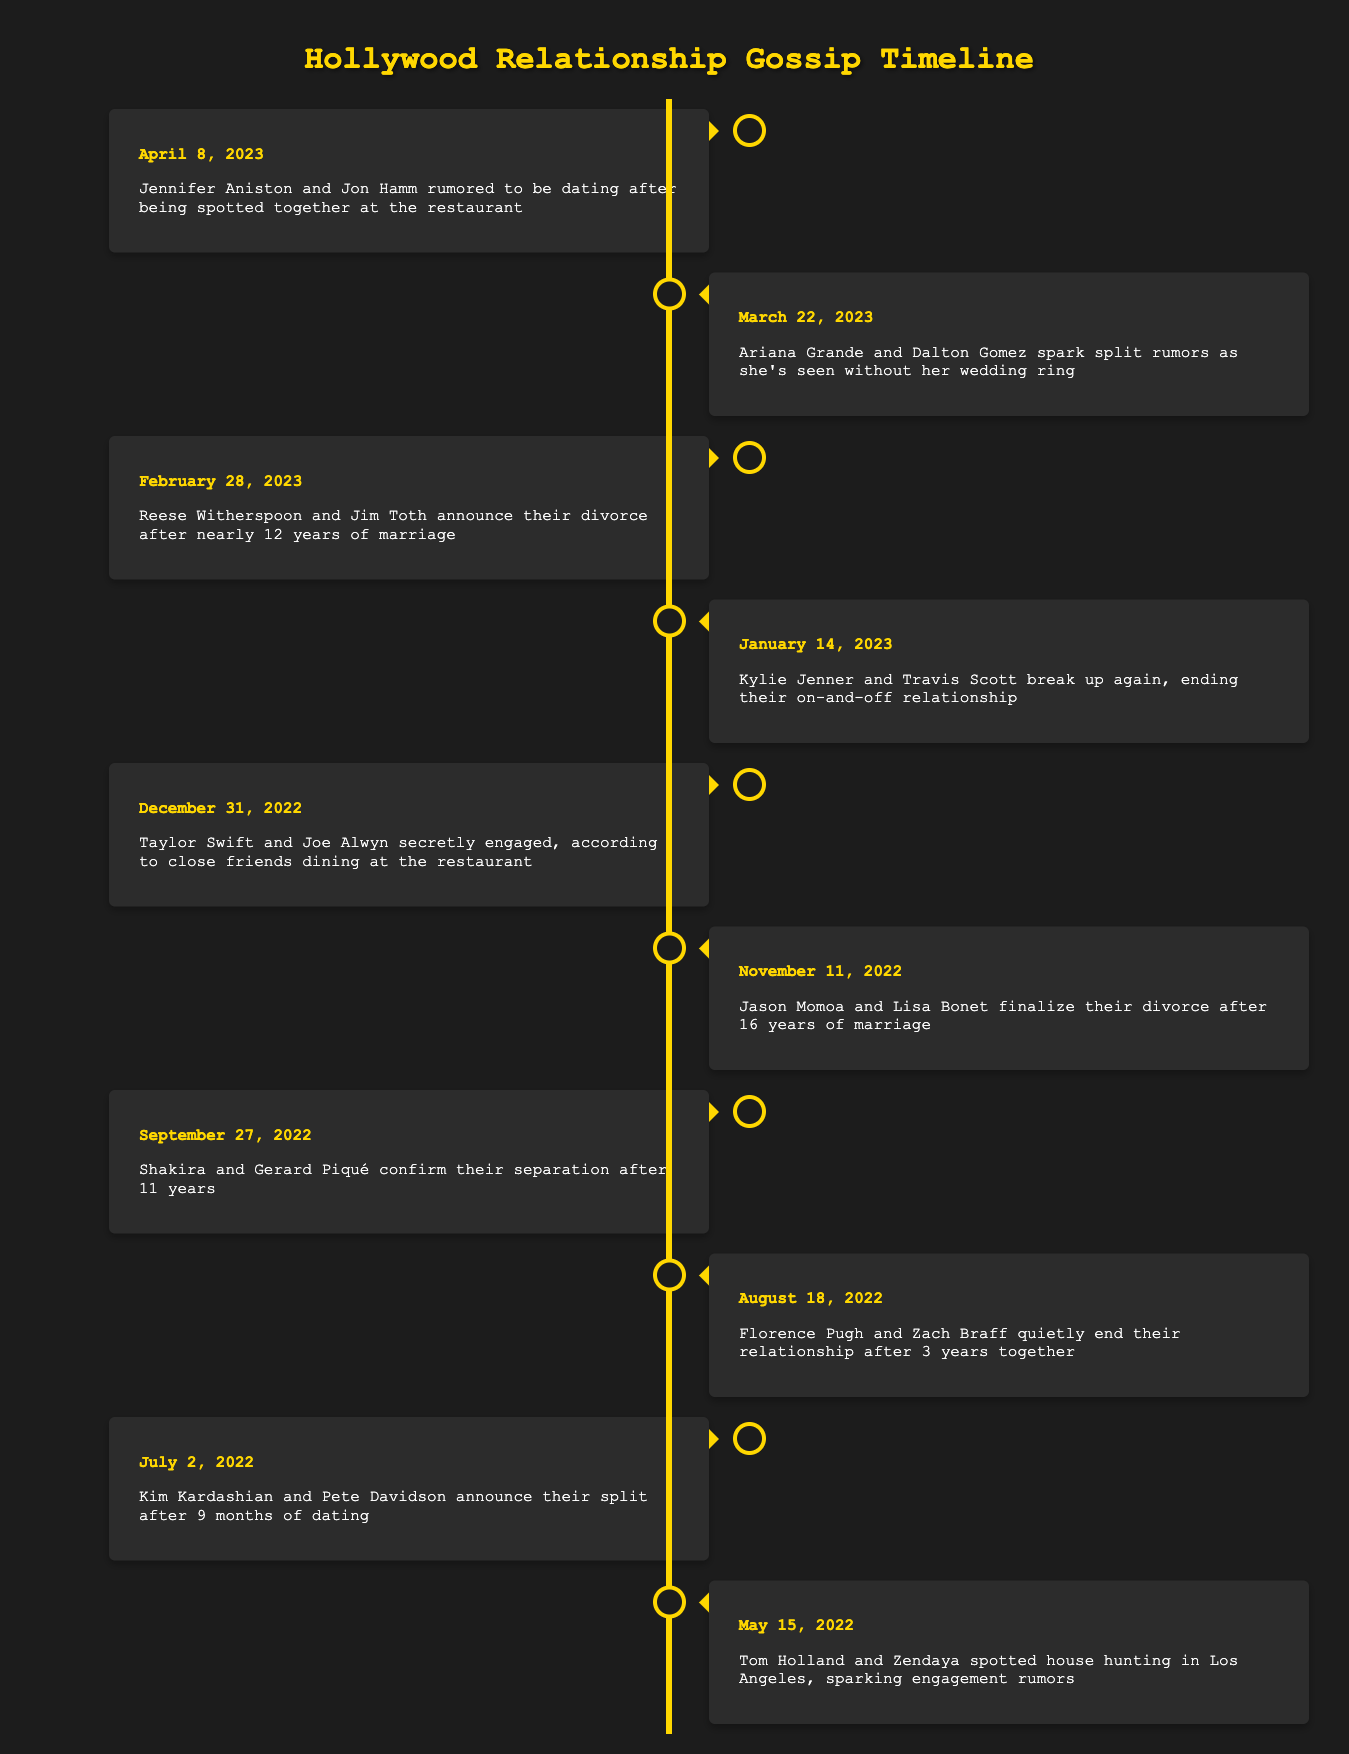What was the date when Tom Holland and Zendaya were first rumored to be engaged? According to the table, the event where Tom Holland and Zendaya were spotted house hunting, sparking engagement rumors, occurred on May 15, 2022.
Answer: May 15, 2022 How many celebrity relationships ended in the timeline provided? By carefully reviewing the events, Kim Kardashian and Pete Davidson, Florence Pugh and Zach Braff, Shakira and Gerard Piqué, Jason Momoa and Lisa Bonet, Kylie Jenner and Travis Scott, and Reese Witherspoon and Jim Toth all ended their relationships. This totals to 6 relationship endings.
Answer: 6 Is it true that Jennifer Aniston was rumored to be dating Jon Hamm? Yes, the table indicates that Jennifer Aniston and Jon Hamm were indeed rumored to be dating after being seen together at the restaurant on April 8, 2023.
Answer: Yes Which couple announced their divorce after the longest marriage? Jason Momoa and Lisa Bonet finalized their divorce after 16 years of marriage, which is longer than any of the other couples listed.
Answer: Jason Momoa and Lisa Bonet What was the first relationship rumor to surface in the timeline? The timeline starts with Tom Holland and Zendaya being spotted house hunting on May 15, 2022, which sparked engagement rumors, making it the first event listed.
Answer: May 15, 2022 How many months were Kim Kardashian and Pete Davidson together before breaking up? Kim Kardashian and Pete Davidson were reported to have announced their split after 9 months of dating as of July 2, 2022.
Answer: 9 months On what date did Kylie Jenner and Travis Scott break up? The timeline indicates that Kylie Jenner and Travis Scott broke up again on January 14, 2023.
Answer: January 14, 2023 Were there any relationships confirmed on December 31, 2022? Yes, the timeline states that Taylor Swift and Joe Alwyn were secretly engaged according to close friends.
Answer: Yes What was the sequence of events concerning divorces in the timeline? The divorces occurred in this sequence: Jason Momoa and Lisa Bonet on November 11, 2022, Reese Witherspoon and Jim Toth on February 28, 2023. This makes two distinct divorce announcements in chronological order.
Answer: Two events 